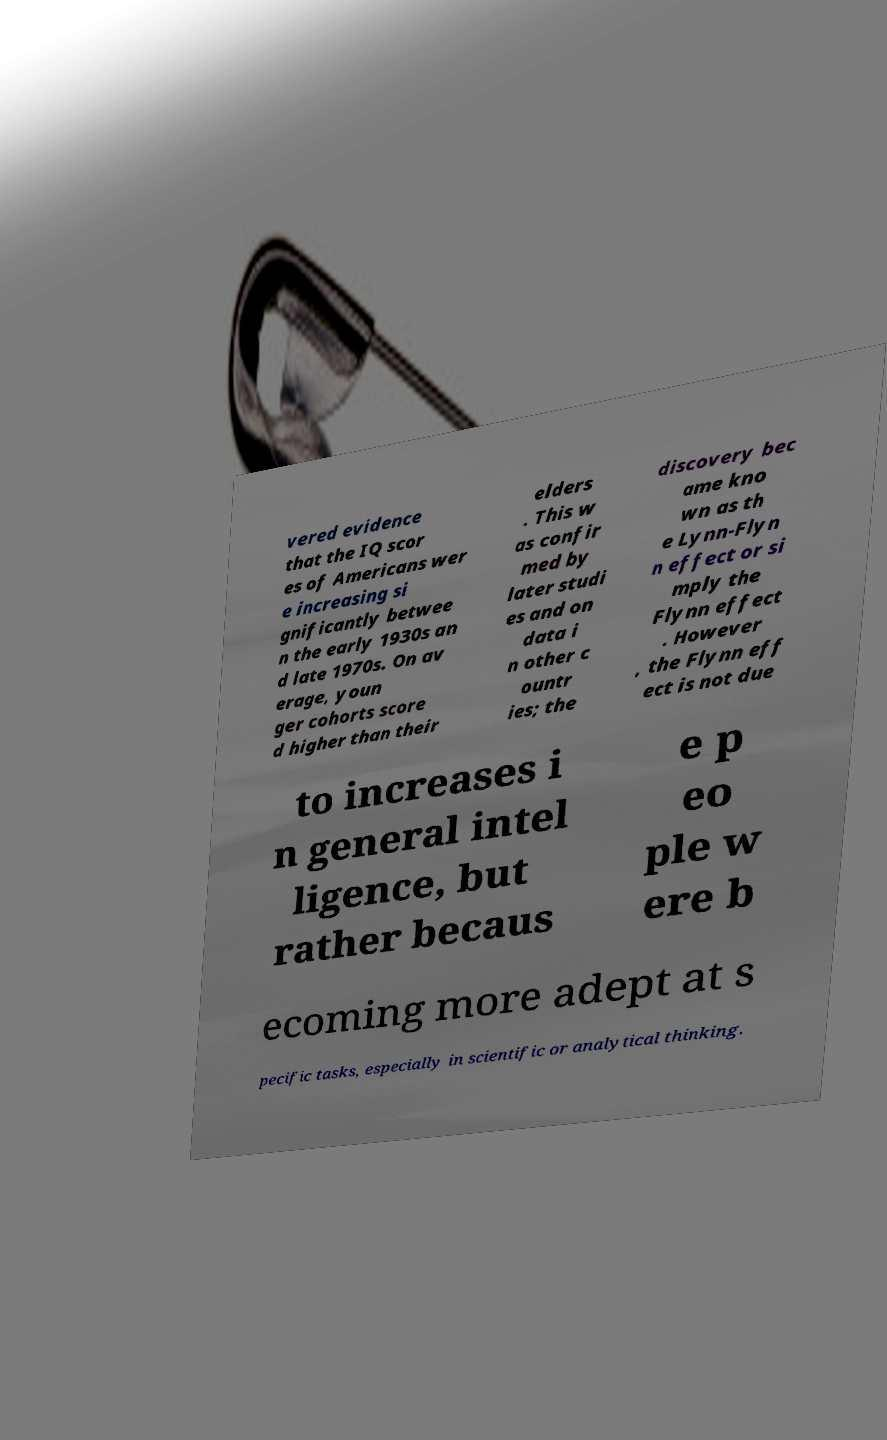Can you read and provide the text displayed in the image?This photo seems to have some interesting text. Can you extract and type it out for me? vered evidence that the IQ scor es of Americans wer e increasing si gnificantly betwee n the early 1930s an d late 1970s. On av erage, youn ger cohorts score d higher than their elders . This w as confir med by later studi es and on data i n other c ountr ies; the discovery bec ame kno wn as th e Lynn-Flyn n effect or si mply the Flynn effect . However , the Flynn eff ect is not due to increases i n general intel ligence, but rather becaus e p eo ple w ere b ecoming more adept at s pecific tasks, especially in scientific or analytical thinking. 